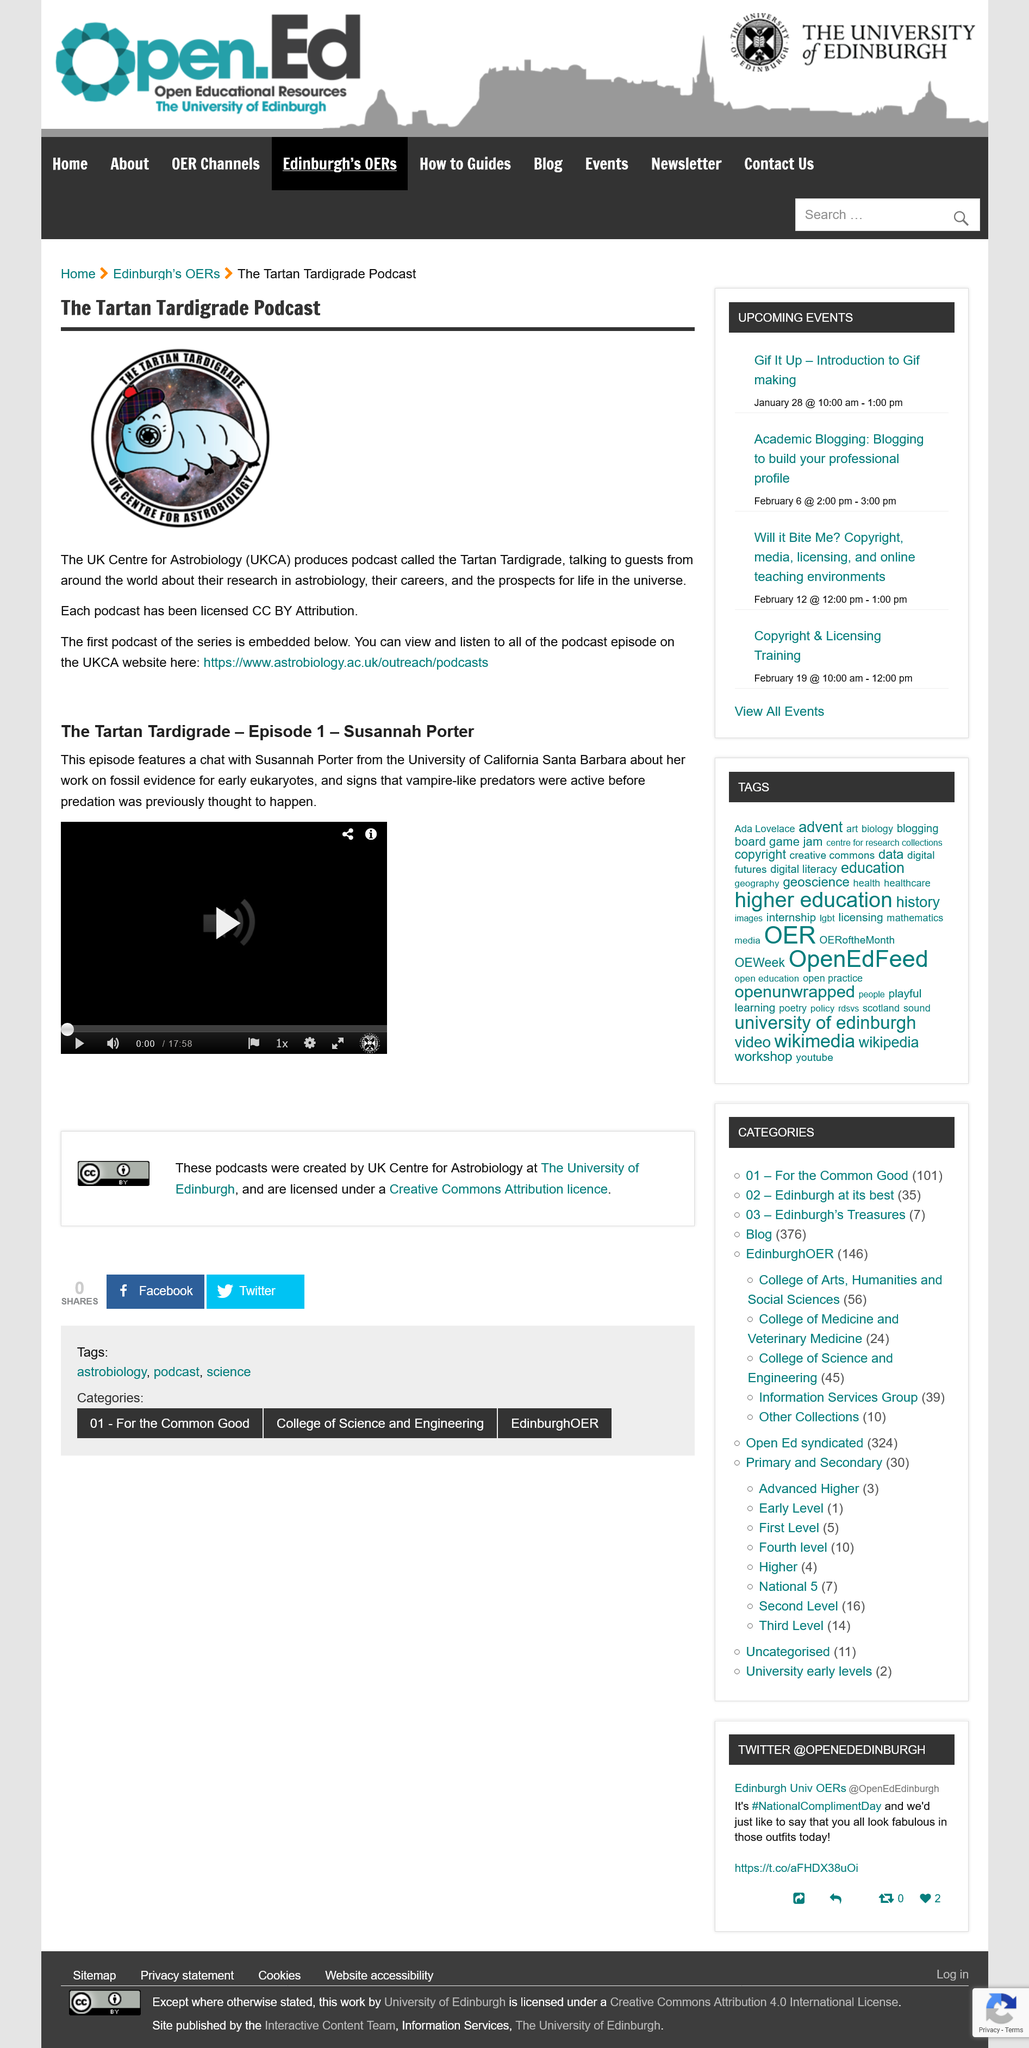Highlight a few significant elements in this photo. The podcasts are licensed under a Creative Commons CC BY Attribution license. The Tartan Tardigrade Podcast is the name of the podcast. The UK Centre for Astrobiology hosts and produces the podcast. 